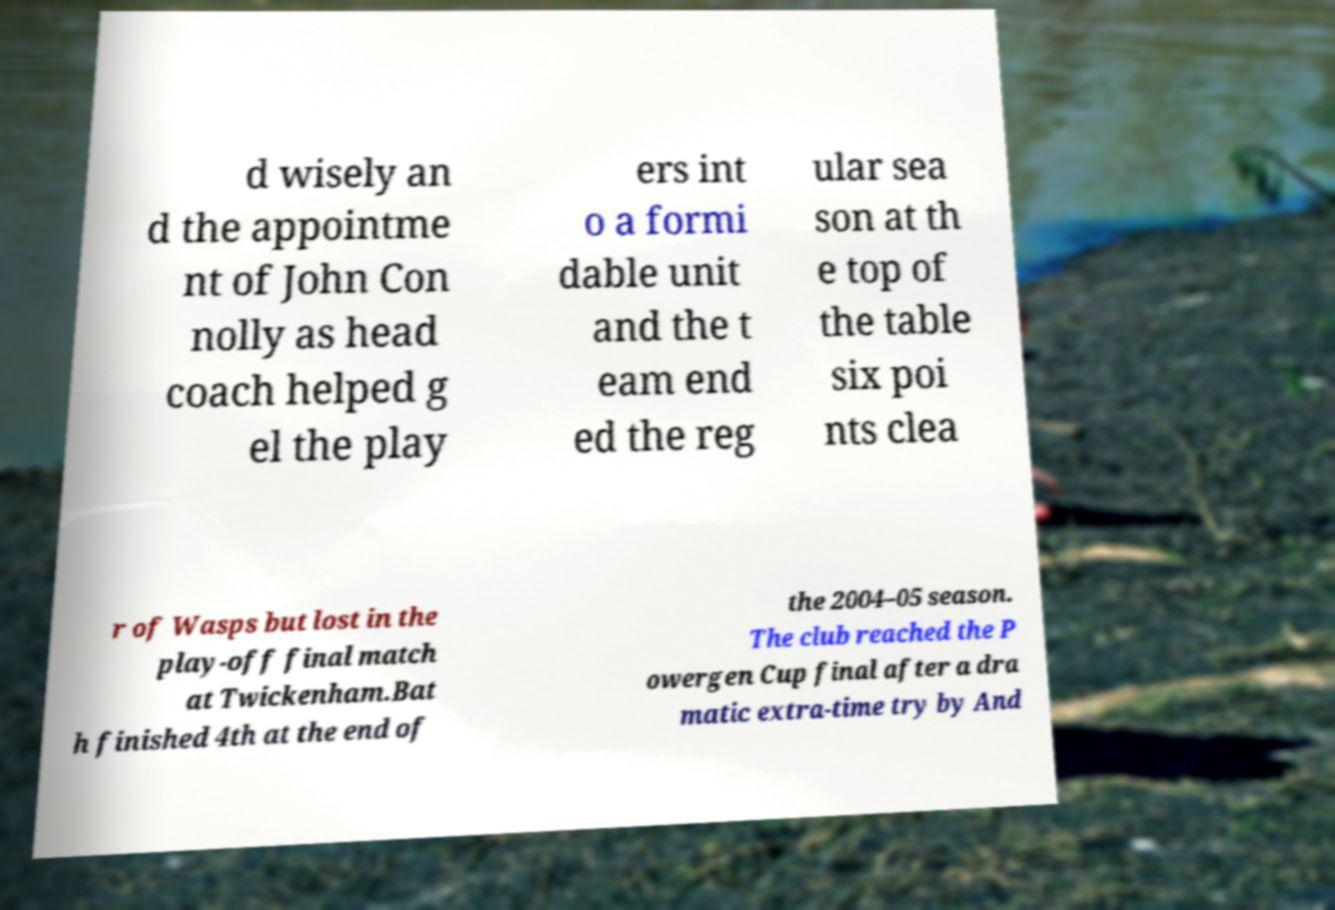For documentation purposes, I need the text within this image transcribed. Could you provide that? d wisely an d the appointme nt of John Con nolly as head coach helped g el the play ers int o a formi dable unit and the t eam end ed the reg ular sea son at th e top of the table six poi nts clea r of Wasps but lost in the play-off final match at Twickenham.Bat h finished 4th at the end of the 2004–05 season. The club reached the P owergen Cup final after a dra matic extra-time try by And 